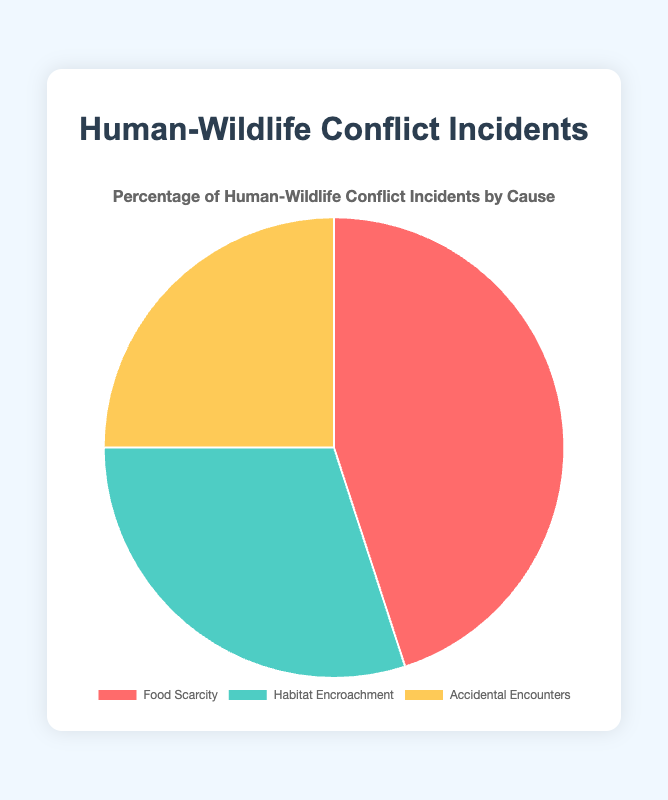What is the percentage of incidents caused by Food Scarcity? The pie chart shows a segment labeled "Food Scarcity" with a corresponding value of 45%.
Answer: 45% What is the difference in percentage between Habitat Encroachment and Accidental Encounters? From the pie chart, the percentage for Habitat Encroachment is 30% and for Accidental Encounters is 25%. The difference is 30% - 25% = 5%.
Answer: 5% Which cause has the highest percentage of human-wildlife conflict incidents? The pie chart segments show that "Food Scarcity" has 45%, "Habitat Encroachment" has 30%, and "Accidental Encounters" has 25%. The highest percentage is for Food Scarcity.
Answer: Food Scarcity What is the combined percentage of incidents caused by Food Scarcity and Habitat Encroachment? Adding the percentages of Food Scarcity (45%) and Habitat Encroachment (30%) gives 45% + 30% = 75%.
Answer: 75% Which cause has the smallest percentage of incidents? The pie chart shows that "Food Scarcity" has 45%, "Habitat Encroachment" has 30%, and "Accidental Encounters" has 25%. The smallest percentage is for Accidental Encounters.
Answer: Accidental Encounters What is the average percentage of incidents across all causes? To find the average, add the percentages of all causes and divide by the number of causes: (45% + 30% + 25%)/3 = 100%/3 ≈ 33.33%.
Answer: 33.33% Is the percentage of incidents caused by Accidental Encounters less than a third of the total incidents? A third of the total incidents is approximately 33.33%. The percentage for Accidental Encounters is 25%, which is less than 33.33%.
Answer: Yes What is the visual color used to represent Accidental Encounters? The pie chart segment for "Accidental Encounters" is shown in a yellow color.
Answer: Yellow 